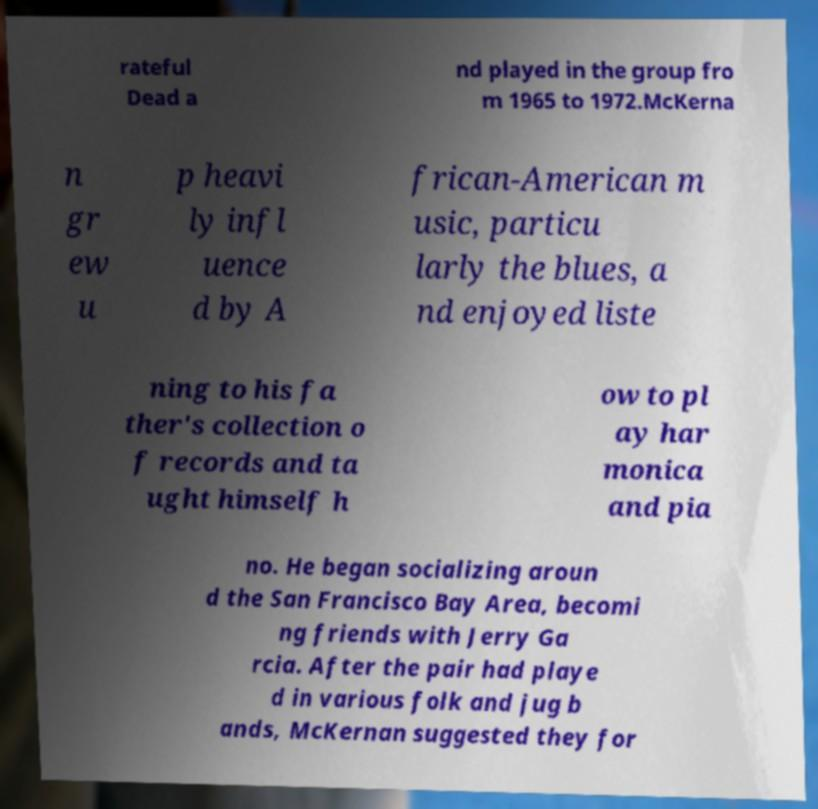What messages or text are displayed in this image? I need them in a readable, typed format. rateful Dead a nd played in the group fro m 1965 to 1972.McKerna n gr ew u p heavi ly infl uence d by A frican-American m usic, particu larly the blues, a nd enjoyed liste ning to his fa ther's collection o f records and ta ught himself h ow to pl ay har monica and pia no. He began socializing aroun d the San Francisco Bay Area, becomi ng friends with Jerry Ga rcia. After the pair had playe d in various folk and jug b ands, McKernan suggested they for 